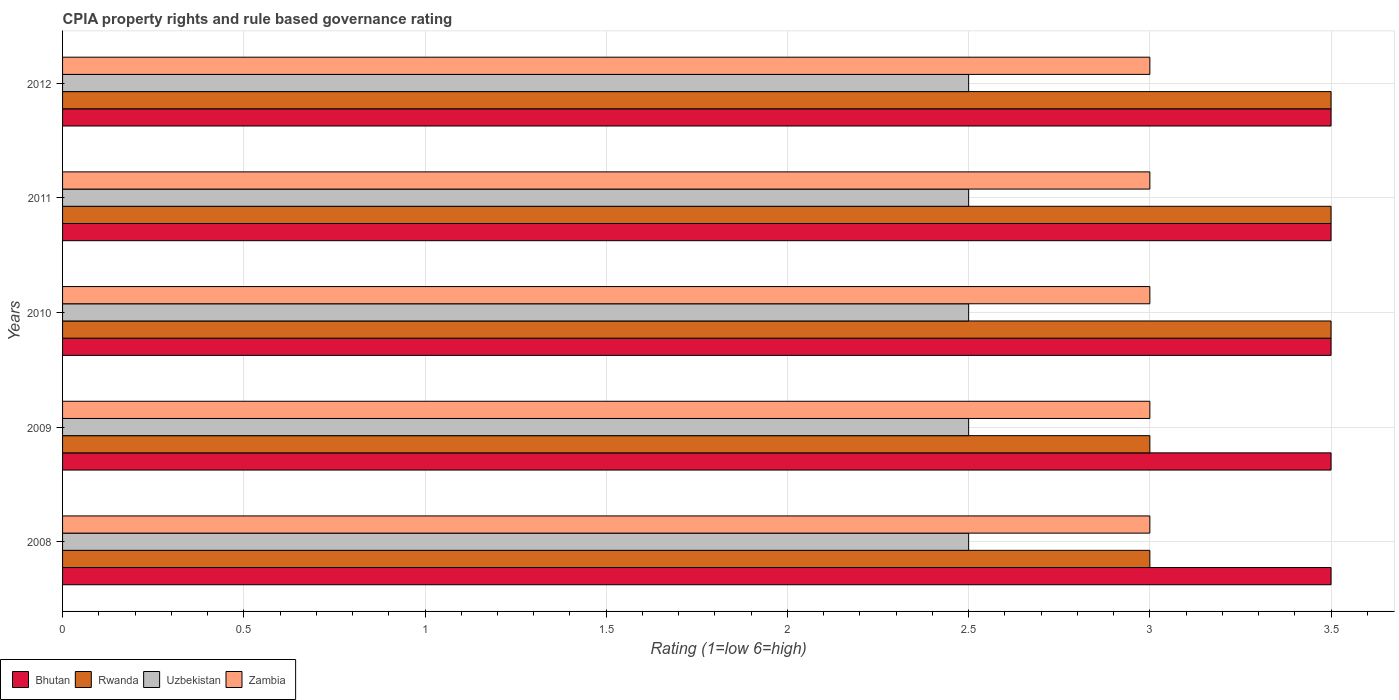Are the number of bars per tick equal to the number of legend labels?
Your answer should be very brief. Yes. Are the number of bars on each tick of the Y-axis equal?
Your answer should be compact. Yes. How many bars are there on the 4th tick from the top?
Provide a succinct answer. 4. In how many cases, is the number of bars for a given year not equal to the number of legend labels?
Your response must be concise. 0. Across all years, what is the maximum CPIA rating in Zambia?
Offer a terse response. 3. Across all years, what is the minimum CPIA rating in Bhutan?
Ensure brevity in your answer.  3.5. In which year was the CPIA rating in Uzbekistan minimum?
Offer a very short reply. 2008. What is the total CPIA rating in Rwanda in the graph?
Offer a terse response. 16.5. What is the average CPIA rating in Rwanda per year?
Your response must be concise. 3.3. In the year 2011, what is the difference between the CPIA rating in Zambia and CPIA rating in Rwanda?
Offer a terse response. -0.5. In how many years, is the CPIA rating in Rwanda greater than 2.7 ?
Provide a short and direct response. 5. What is the ratio of the CPIA rating in Bhutan in 2010 to that in 2012?
Offer a very short reply. 1. Is the CPIA rating in Zambia in 2009 less than that in 2011?
Offer a terse response. No. In how many years, is the CPIA rating in Zambia greater than the average CPIA rating in Zambia taken over all years?
Your answer should be compact. 0. What does the 4th bar from the top in 2010 represents?
Your answer should be very brief. Bhutan. What does the 4th bar from the bottom in 2008 represents?
Your response must be concise. Zambia. Is it the case that in every year, the sum of the CPIA rating in Rwanda and CPIA rating in Uzbekistan is greater than the CPIA rating in Bhutan?
Your answer should be compact. Yes. How many bars are there?
Your response must be concise. 20. Are all the bars in the graph horizontal?
Ensure brevity in your answer.  Yes. How many years are there in the graph?
Offer a terse response. 5. Are the values on the major ticks of X-axis written in scientific E-notation?
Provide a succinct answer. No. Does the graph contain grids?
Offer a very short reply. Yes. How many legend labels are there?
Your answer should be very brief. 4. What is the title of the graph?
Your response must be concise. CPIA property rights and rule based governance rating. What is the label or title of the X-axis?
Provide a short and direct response. Rating (1=low 6=high). What is the Rating (1=low 6=high) in Bhutan in 2008?
Ensure brevity in your answer.  3.5. What is the Rating (1=low 6=high) in Rwanda in 2008?
Keep it short and to the point. 3. What is the Rating (1=low 6=high) in Uzbekistan in 2008?
Your answer should be very brief. 2.5. What is the Rating (1=low 6=high) in Zambia in 2008?
Provide a short and direct response. 3. What is the Rating (1=low 6=high) of Bhutan in 2009?
Make the answer very short. 3.5. What is the Rating (1=low 6=high) of Uzbekistan in 2009?
Provide a succinct answer. 2.5. What is the Rating (1=low 6=high) in Zambia in 2009?
Offer a very short reply. 3. What is the Rating (1=low 6=high) of Rwanda in 2010?
Offer a terse response. 3.5. What is the Rating (1=low 6=high) in Zambia in 2010?
Provide a succinct answer. 3. What is the Rating (1=low 6=high) of Bhutan in 2011?
Offer a terse response. 3.5. What is the Rating (1=low 6=high) of Rwanda in 2011?
Give a very brief answer. 3.5. What is the Rating (1=low 6=high) in Zambia in 2011?
Your answer should be very brief. 3. What is the Rating (1=low 6=high) of Bhutan in 2012?
Your answer should be compact. 3.5. What is the Rating (1=low 6=high) of Rwanda in 2012?
Offer a terse response. 3.5. What is the Rating (1=low 6=high) in Uzbekistan in 2012?
Your response must be concise. 2.5. What is the Rating (1=low 6=high) in Zambia in 2012?
Provide a short and direct response. 3. Across all years, what is the maximum Rating (1=low 6=high) of Bhutan?
Your answer should be compact. 3.5. Across all years, what is the maximum Rating (1=low 6=high) in Rwanda?
Provide a short and direct response. 3.5. Across all years, what is the maximum Rating (1=low 6=high) in Uzbekistan?
Provide a short and direct response. 2.5. Across all years, what is the minimum Rating (1=low 6=high) in Bhutan?
Keep it short and to the point. 3.5. Across all years, what is the minimum Rating (1=low 6=high) of Rwanda?
Offer a terse response. 3. What is the total Rating (1=low 6=high) of Rwanda in the graph?
Make the answer very short. 16.5. What is the difference between the Rating (1=low 6=high) of Zambia in 2008 and that in 2009?
Make the answer very short. 0. What is the difference between the Rating (1=low 6=high) in Rwanda in 2008 and that in 2010?
Make the answer very short. -0.5. What is the difference between the Rating (1=low 6=high) in Zambia in 2008 and that in 2010?
Give a very brief answer. 0. What is the difference between the Rating (1=low 6=high) of Zambia in 2008 and that in 2011?
Your response must be concise. 0. What is the difference between the Rating (1=low 6=high) of Bhutan in 2008 and that in 2012?
Offer a terse response. 0. What is the difference between the Rating (1=low 6=high) of Bhutan in 2009 and that in 2010?
Your response must be concise. 0. What is the difference between the Rating (1=low 6=high) of Uzbekistan in 2009 and that in 2010?
Give a very brief answer. 0. What is the difference between the Rating (1=low 6=high) in Zambia in 2009 and that in 2010?
Offer a very short reply. 0. What is the difference between the Rating (1=low 6=high) of Rwanda in 2009 and that in 2011?
Offer a terse response. -0.5. What is the difference between the Rating (1=low 6=high) of Uzbekistan in 2009 and that in 2011?
Make the answer very short. 0. What is the difference between the Rating (1=low 6=high) in Zambia in 2009 and that in 2011?
Your answer should be very brief. 0. What is the difference between the Rating (1=low 6=high) of Bhutan in 2009 and that in 2012?
Provide a short and direct response. 0. What is the difference between the Rating (1=low 6=high) of Uzbekistan in 2009 and that in 2012?
Your answer should be compact. 0. What is the difference between the Rating (1=low 6=high) of Uzbekistan in 2010 and that in 2011?
Make the answer very short. 0. What is the difference between the Rating (1=low 6=high) in Bhutan in 2010 and that in 2012?
Provide a succinct answer. 0. What is the difference between the Rating (1=low 6=high) in Rwanda in 2010 and that in 2012?
Make the answer very short. 0. What is the difference between the Rating (1=low 6=high) of Uzbekistan in 2010 and that in 2012?
Your answer should be compact. 0. What is the difference between the Rating (1=low 6=high) in Bhutan in 2011 and that in 2012?
Make the answer very short. 0. What is the difference between the Rating (1=low 6=high) of Rwanda in 2011 and that in 2012?
Give a very brief answer. 0. What is the difference between the Rating (1=low 6=high) of Zambia in 2011 and that in 2012?
Keep it short and to the point. 0. What is the difference between the Rating (1=low 6=high) of Bhutan in 2008 and the Rating (1=low 6=high) of Rwanda in 2009?
Your answer should be compact. 0.5. What is the difference between the Rating (1=low 6=high) of Bhutan in 2008 and the Rating (1=low 6=high) of Rwanda in 2010?
Keep it short and to the point. 0. What is the difference between the Rating (1=low 6=high) of Bhutan in 2008 and the Rating (1=low 6=high) of Uzbekistan in 2010?
Provide a succinct answer. 1. What is the difference between the Rating (1=low 6=high) in Rwanda in 2008 and the Rating (1=low 6=high) in Zambia in 2010?
Offer a terse response. 0. What is the difference between the Rating (1=low 6=high) in Bhutan in 2008 and the Rating (1=low 6=high) in Rwanda in 2011?
Your response must be concise. 0. What is the difference between the Rating (1=low 6=high) of Bhutan in 2008 and the Rating (1=low 6=high) of Zambia in 2011?
Give a very brief answer. 0.5. What is the difference between the Rating (1=low 6=high) in Rwanda in 2008 and the Rating (1=low 6=high) in Uzbekistan in 2011?
Your answer should be compact. 0.5. What is the difference between the Rating (1=low 6=high) of Rwanda in 2008 and the Rating (1=low 6=high) of Zambia in 2011?
Your answer should be compact. 0. What is the difference between the Rating (1=low 6=high) of Bhutan in 2008 and the Rating (1=low 6=high) of Rwanda in 2012?
Give a very brief answer. 0. What is the difference between the Rating (1=low 6=high) of Bhutan in 2008 and the Rating (1=low 6=high) of Zambia in 2012?
Your answer should be very brief. 0.5. What is the difference between the Rating (1=low 6=high) of Uzbekistan in 2008 and the Rating (1=low 6=high) of Zambia in 2012?
Your answer should be compact. -0.5. What is the difference between the Rating (1=low 6=high) of Bhutan in 2009 and the Rating (1=low 6=high) of Uzbekistan in 2010?
Your answer should be compact. 1. What is the difference between the Rating (1=low 6=high) in Rwanda in 2009 and the Rating (1=low 6=high) in Uzbekistan in 2010?
Ensure brevity in your answer.  0.5. What is the difference between the Rating (1=low 6=high) of Uzbekistan in 2009 and the Rating (1=low 6=high) of Zambia in 2010?
Offer a very short reply. -0.5. What is the difference between the Rating (1=low 6=high) in Rwanda in 2009 and the Rating (1=low 6=high) in Zambia in 2011?
Offer a very short reply. 0. What is the difference between the Rating (1=low 6=high) of Bhutan in 2009 and the Rating (1=low 6=high) of Rwanda in 2012?
Offer a terse response. 0. What is the difference between the Rating (1=low 6=high) in Bhutan in 2009 and the Rating (1=low 6=high) in Zambia in 2012?
Offer a very short reply. 0.5. What is the difference between the Rating (1=low 6=high) of Uzbekistan in 2009 and the Rating (1=low 6=high) of Zambia in 2012?
Ensure brevity in your answer.  -0.5. What is the difference between the Rating (1=low 6=high) in Bhutan in 2010 and the Rating (1=low 6=high) in Zambia in 2011?
Your answer should be compact. 0.5. What is the difference between the Rating (1=low 6=high) of Rwanda in 2010 and the Rating (1=low 6=high) of Zambia in 2011?
Give a very brief answer. 0.5. What is the difference between the Rating (1=low 6=high) in Uzbekistan in 2010 and the Rating (1=low 6=high) in Zambia in 2011?
Give a very brief answer. -0.5. What is the difference between the Rating (1=low 6=high) of Bhutan in 2010 and the Rating (1=low 6=high) of Uzbekistan in 2012?
Offer a terse response. 1. What is the difference between the Rating (1=low 6=high) in Bhutan in 2010 and the Rating (1=low 6=high) in Zambia in 2012?
Offer a terse response. 0.5. What is the difference between the Rating (1=low 6=high) in Rwanda in 2010 and the Rating (1=low 6=high) in Zambia in 2012?
Give a very brief answer. 0.5. What is the difference between the Rating (1=low 6=high) in Bhutan in 2011 and the Rating (1=low 6=high) in Rwanda in 2012?
Your response must be concise. 0. What is the difference between the Rating (1=low 6=high) in Rwanda in 2011 and the Rating (1=low 6=high) in Uzbekistan in 2012?
Provide a short and direct response. 1. What is the difference between the Rating (1=low 6=high) of Rwanda in 2011 and the Rating (1=low 6=high) of Zambia in 2012?
Your answer should be very brief. 0.5. What is the average Rating (1=low 6=high) in Rwanda per year?
Provide a succinct answer. 3.3. What is the average Rating (1=low 6=high) in Uzbekistan per year?
Keep it short and to the point. 2.5. In the year 2008, what is the difference between the Rating (1=low 6=high) of Bhutan and Rating (1=low 6=high) of Uzbekistan?
Your answer should be very brief. 1. In the year 2008, what is the difference between the Rating (1=low 6=high) of Rwanda and Rating (1=low 6=high) of Uzbekistan?
Your response must be concise. 0.5. In the year 2008, what is the difference between the Rating (1=low 6=high) of Rwanda and Rating (1=low 6=high) of Zambia?
Provide a succinct answer. 0. In the year 2008, what is the difference between the Rating (1=low 6=high) in Uzbekistan and Rating (1=low 6=high) in Zambia?
Provide a short and direct response. -0.5. In the year 2009, what is the difference between the Rating (1=low 6=high) of Bhutan and Rating (1=low 6=high) of Rwanda?
Provide a short and direct response. 0.5. In the year 2009, what is the difference between the Rating (1=low 6=high) of Bhutan and Rating (1=low 6=high) of Uzbekistan?
Offer a terse response. 1. In the year 2009, what is the difference between the Rating (1=low 6=high) of Rwanda and Rating (1=low 6=high) of Uzbekistan?
Your answer should be compact. 0.5. In the year 2010, what is the difference between the Rating (1=low 6=high) in Bhutan and Rating (1=low 6=high) in Rwanda?
Keep it short and to the point. 0. In the year 2010, what is the difference between the Rating (1=low 6=high) of Uzbekistan and Rating (1=low 6=high) of Zambia?
Offer a terse response. -0.5. In the year 2011, what is the difference between the Rating (1=low 6=high) in Bhutan and Rating (1=low 6=high) in Rwanda?
Provide a short and direct response. 0. In the year 2011, what is the difference between the Rating (1=low 6=high) of Bhutan and Rating (1=low 6=high) of Uzbekistan?
Offer a terse response. 1. In the year 2012, what is the difference between the Rating (1=low 6=high) of Rwanda and Rating (1=low 6=high) of Zambia?
Make the answer very short. 0.5. What is the ratio of the Rating (1=low 6=high) in Zambia in 2008 to that in 2009?
Make the answer very short. 1. What is the ratio of the Rating (1=low 6=high) of Rwanda in 2008 to that in 2010?
Offer a terse response. 0.86. What is the ratio of the Rating (1=low 6=high) of Zambia in 2008 to that in 2010?
Ensure brevity in your answer.  1. What is the ratio of the Rating (1=low 6=high) in Uzbekistan in 2008 to that in 2011?
Give a very brief answer. 1. What is the ratio of the Rating (1=low 6=high) of Zambia in 2008 to that in 2012?
Your response must be concise. 1. What is the ratio of the Rating (1=low 6=high) in Uzbekistan in 2009 to that in 2010?
Give a very brief answer. 1. What is the ratio of the Rating (1=low 6=high) of Zambia in 2009 to that in 2010?
Keep it short and to the point. 1. What is the ratio of the Rating (1=low 6=high) of Rwanda in 2009 to that in 2011?
Provide a succinct answer. 0.86. What is the ratio of the Rating (1=low 6=high) of Zambia in 2009 to that in 2011?
Provide a short and direct response. 1. What is the ratio of the Rating (1=low 6=high) of Uzbekistan in 2009 to that in 2012?
Your answer should be compact. 1. What is the ratio of the Rating (1=low 6=high) in Zambia in 2009 to that in 2012?
Your answer should be very brief. 1. What is the ratio of the Rating (1=low 6=high) of Bhutan in 2010 to that in 2011?
Offer a very short reply. 1. What is the ratio of the Rating (1=low 6=high) in Rwanda in 2010 to that in 2011?
Your answer should be compact. 1. What is the ratio of the Rating (1=low 6=high) in Uzbekistan in 2010 to that in 2011?
Offer a very short reply. 1. What is the ratio of the Rating (1=low 6=high) in Rwanda in 2010 to that in 2012?
Ensure brevity in your answer.  1. What is the ratio of the Rating (1=low 6=high) in Zambia in 2010 to that in 2012?
Ensure brevity in your answer.  1. What is the ratio of the Rating (1=low 6=high) in Bhutan in 2011 to that in 2012?
Provide a short and direct response. 1. What is the difference between the highest and the second highest Rating (1=low 6=high) in Rwanda?
Give a very brief answer. 0. What is the difference between the highest and the lowest Rating (1=low 6=high) in Bhutan?
Provide a short and direct response. 0. What is the difference between the highest and the lowest Rating (1=low 6=high) of Uzbekistan?
Provide a succinct answer. 0. What is the difference between the highest and the lowest Rating (1=low 6=high) of Zambia?
Give a very brief answer. 0. 